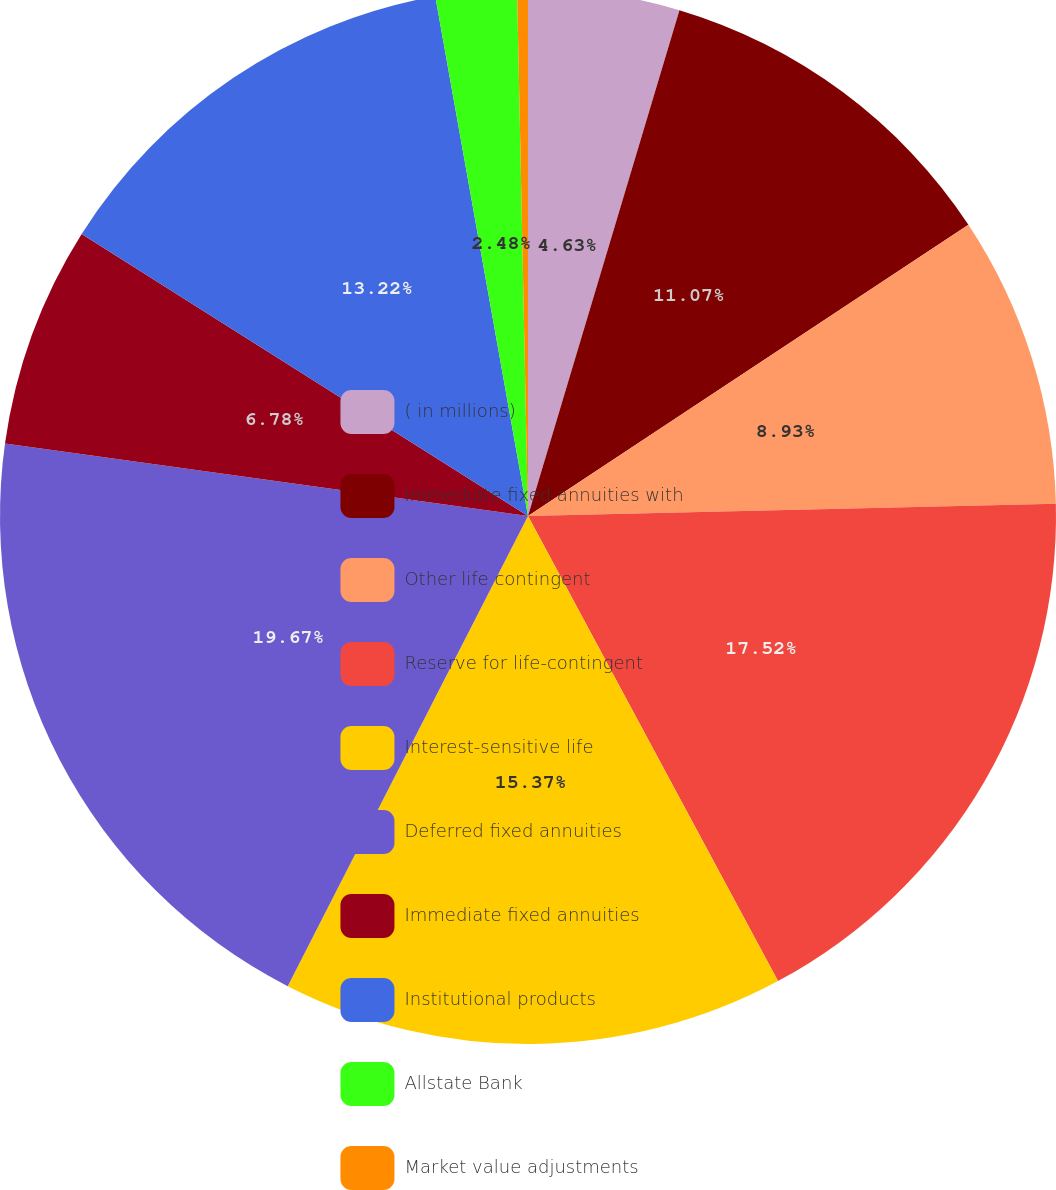<chart> <loc_0><loc_0><loc_500><loc_500><pie_chart><fcel>( in millions)<fcel>Immediate fixed annuities with<fcel>Other life contingent<fcel>Reserve for life-contingent<fcel>Interest-sensitive life<fcel>Deferred fixed annuities<fcel>Immediate fixed annuities<fcel>Institutional products<fcel>Allstate Bank<fcel>Market value adjustments<nl><fcel>4.63%<fcel>11.07%<fcel>8.93%<fcel>17.52%<fcel>15.37%<fcel>19.67%<fcel>6.78%<fcel>13.22%<fcel>2.48%<fcel>0.33%<nl></chart> 